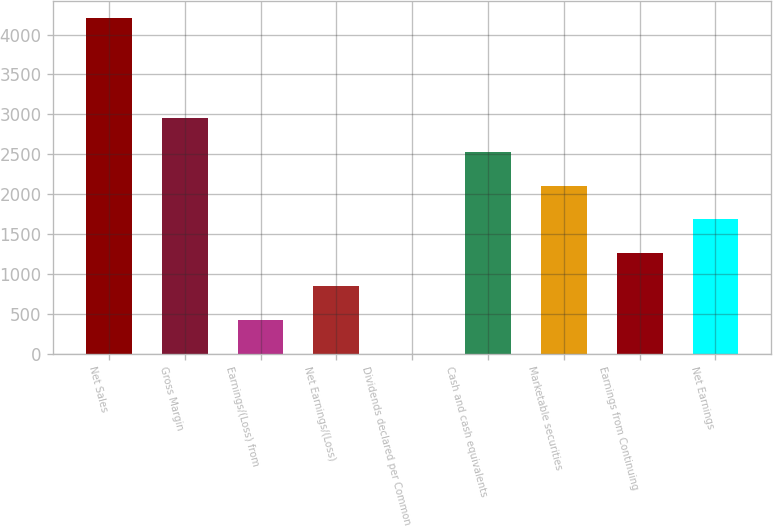<chart> <loc_0><loc_0><loc_500><loc_500><bar_chart><fcel>Net Sales<fcel>Gross Margin<fcel>Earnings/(Loss) from<fcel>Net Earnings/(Loss)<fcel>Dividends declared per Common<fcel>Cash and cash equivalents<fcel>Marketable securities<fcel>Earnings from Continuing<fcel>Net Earnings<nl><fcel>4213<fcel>2949.17<fcel>421.55<fcel>842.82<fcel>0.28<fcel>2527.9<fcel>2106.63<fcel>1264.09<fcel>1685.36<nl></chart> 